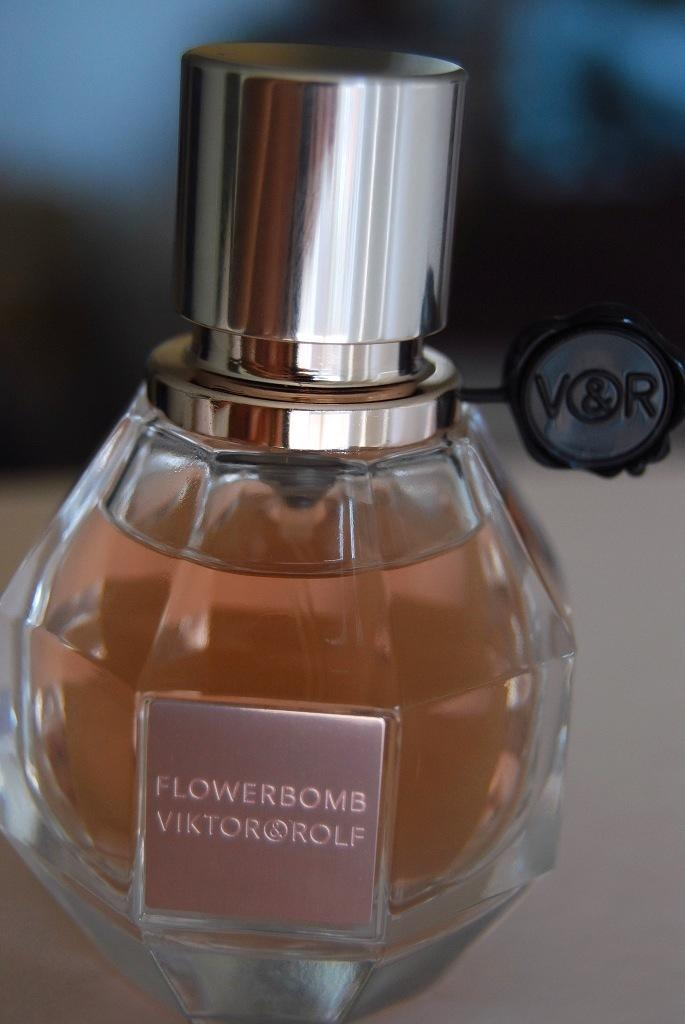<image>
Render a clear and concise summary of the photo. A closeup of a bottle of Viktor and Rolf Flowerbomb perfume. 